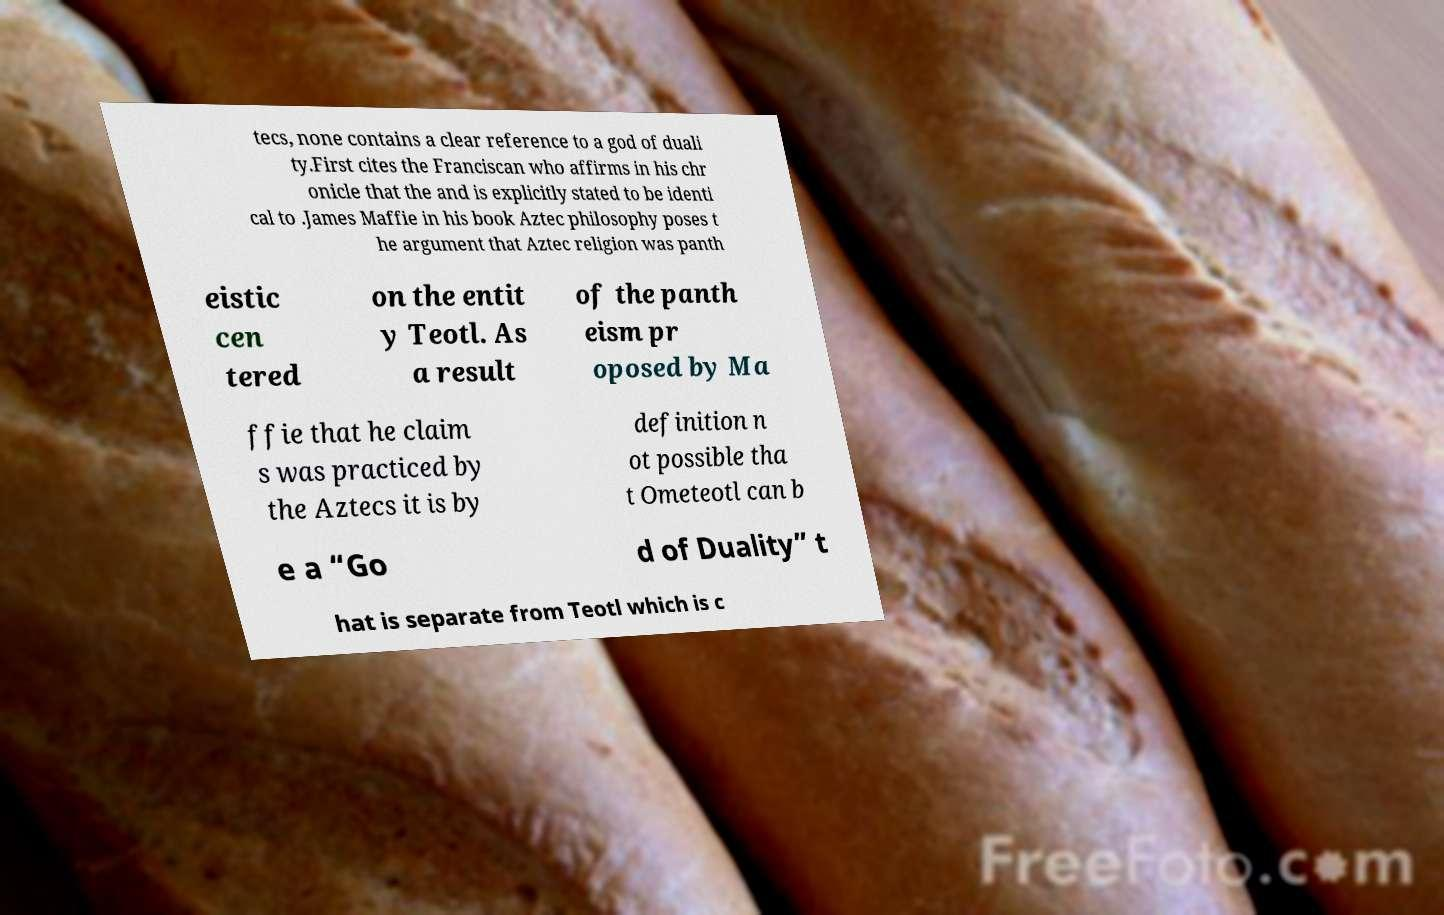What messages or text are displayed in this image? I need them in a readable, typed format. tecs, none contains a clear reference to a god of duali ty.First cites the Franciscan who affirms in his chr onicle that the and is explicitly stated to be identi cal to .James Maffie in his book Aztec philosophy poses t he argument that Aztec religion was panth eistic cen tered on the entit y Teotl. As a result of the panth eism pr oposed by Ma ffie that he claim s was practiced by the Aztecs it is by definition n ot possible tha t Ometeotl can b e a “Go d of Duality” t hat is separate from Teotl which is c 